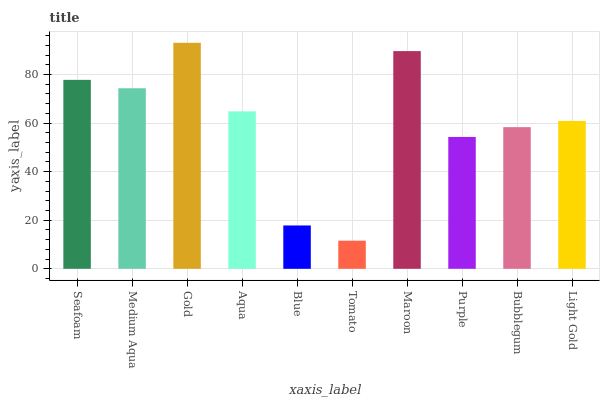Is Tomato the minimum?
Answer yes or no. Yes. Is Gold the maximum?
Answer yes or no. Yes. Is Medium Aqua the minimum?
Answer yes or no. No. Is Medium Aqua the maximum?
Answer yes or no. No. Is Seafoam greater than Medium Aqua?
Answer yes or no. Yes. Is Medium Aqua less than Seafoam?
Answer yes or no. Yes. Is Medium Aqua greater than Seafoam?
Answer yes or no. No. Is Seafoam less than Medium Aqua?
Answer yes or no. No. Is Aqua the high median?
Answer yes or no. Yes. Is Light Gold the low median?
Answer yes or no. Yes. Is Tomato the high median?
Answer yes or no. No. Is Tomato the low median?
Answer yes or no. No. 